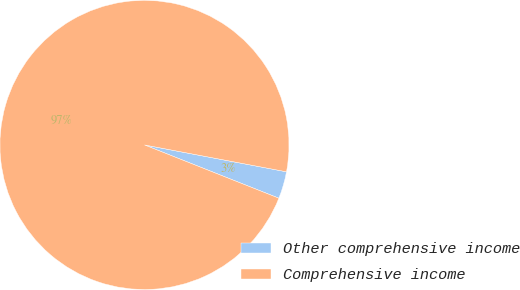Convert chart to OTSL. <chart><loc_0><loc_0><loc_500><loc_500><pie_chart><fcel>Other comprehensive income<fcel>Comprehensive income<nl><fcel>3.03%<fcel>96.97%<nl></chart> 